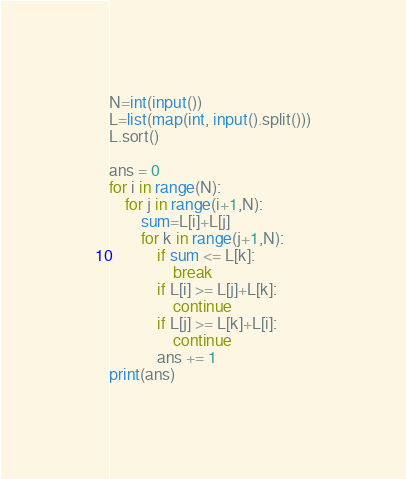Convert code to text. <code><loc_0><loc_0><loc_500><loc_500><_Python_>N=int(input())
L=list(map(int, input().split()))
L.sort()

ans = 0
for i in range(N):
    for j in range(i+1,N):
        sum=L[i]+L[j]
        for k in range(j+1,N):
            if sum <= L[k]:
                break
            if L[i] >= L[j]+L[k]:
                continue
            if L[j] >= L[k]+L[i]:
                continue
            ans += 1
print(ans)</code> 